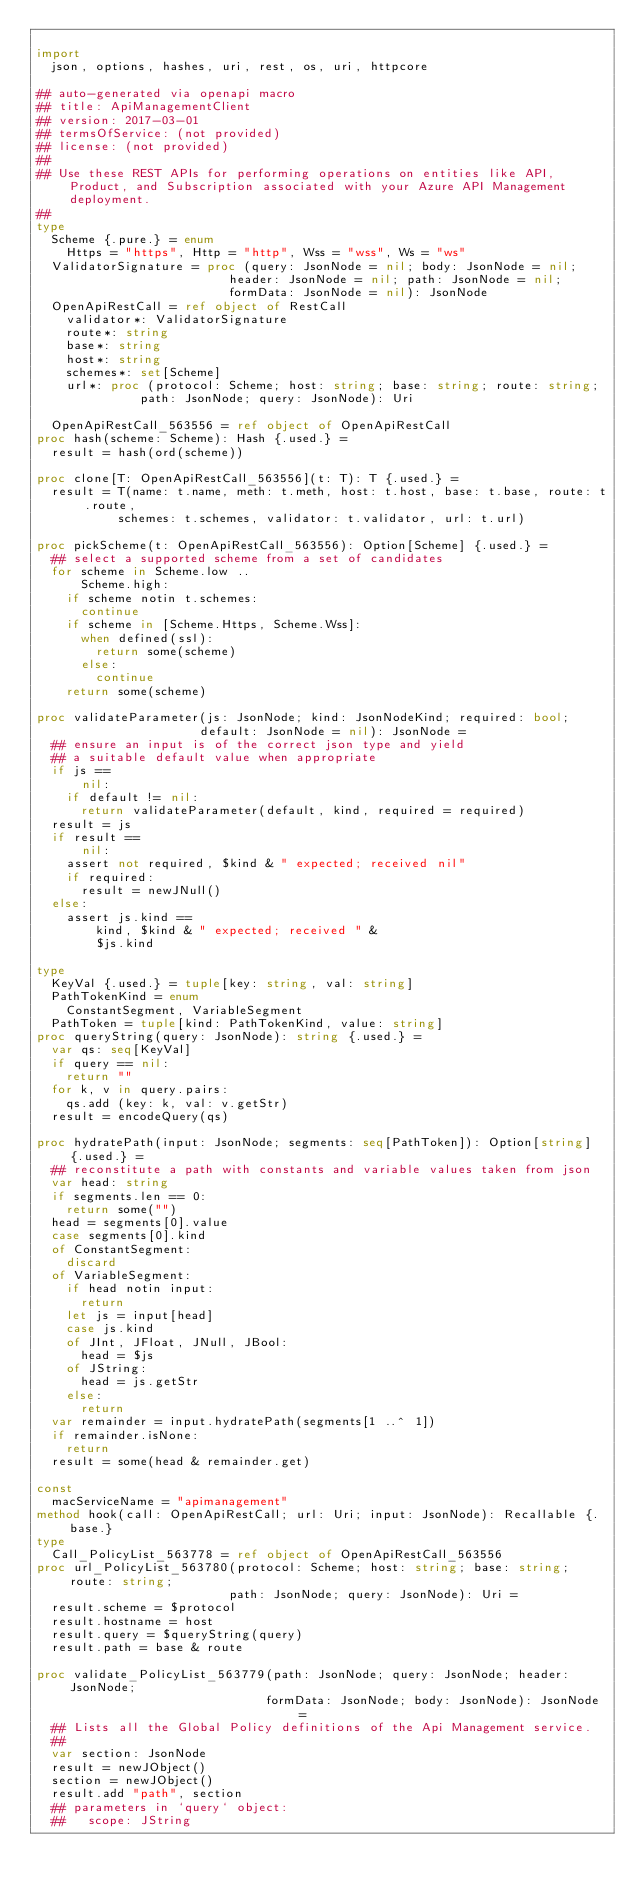Convert code to text. <code><loc_0><loc_0><loc_500><loc_500><_Nim_>
import
  json, options, hashes, uri, rest, os, uri, httpcore

## auto-generated via openapi macro
## title: ApiManagementClient
## version: 2017-03-01
## termsOfService: (not provided)
## license: (not provided)
## 
## Use these REST APIs for performing operations on entities like API, Product, and Subscription associated with your Azure API Management deployment.
## 
type
  Scheme {.pure.} = enum
    Https = "https", Http = "http", Wss = "wss", Ws = "ws"
  ValidatorSignature = proc (query: JsonNode = nil; body: JsonNode = nil;
                          header: JsonNode = nil; path: JsonNode = nil;
                          formData: JsonNode = nil): JsonNode
  OpenApiRestCall = ref object of RestCall
    validator*: ValidatorSignature
    route*: string
    base*: string
    host*: string
    schemes*: set[Scheme]
    url*: proc (protocol: Scheme; host: string; base: string; route: string;
              path: JsonNode; query: JsonNode): Uri

  OpenApiRestCall_563556 = ref object of OpenApiRestCall
proc hash(scheme: Scheme): Hash {.used.} =
  result = hash(ord(scheme))

proc clone[T: OpenApiRestCall_563556](t: T): T {.used.} =
  result = T(name: t.name, meth: t.meth, host: t.host, base: t.base, route: t.route,
           schemes: t.schemes, validator: t.validator, url: t.url)

proc pickScheme(t: OpenApiRestCall_563556): Option[Scheme] {.used.} =
  ## select a supported scheme from a set of candidates
  for scheme in Scheme.low ..
      Scheme.high:
    if scheme notin t.schemes:
      continue
    if scheme in [Scheme.Https, Scheme.Wss]:
      when defined(ssl):
        return some(scheme)
      else:
        continue
    return some(scheme)

proc validateParameter(js: JsonNode; kind: JsonNodeKind; required: bool;
                      default: JsonNode = nil): JsonNode =
  ## ensure an input is of the correct json type and yield
  ## a suitable default value when appropriate
  if js ==
      nil:
    if default != nil:
      return validateParameter(default, kind, required = required)
  result = js
  if result ==
      nil:
    assert not required, $kind & " expected; received nil"
    if required:
      result = newJNull()
  else:
    assert js.kind ==
        kind, $kind & " expected; received " &
        $js.kind

type
  KeyVal {.used.} = tuple[key: string, val: string]
  PathTokenKind = enum
    ConstantSegment, VariableSegment
  PathToken = tuple[kind: PathTokenKind, value: string]
proc queryString(query: JsonNode): string {.used.} =
  var qs: seq[KeyVal]
  if query == nil:
    return ""
  for k, v in query.pairs:
    qs.add (key: k, val: v.getStr)
  result = encodeQuery(qs)

proc hydratePath(input: JsonNode; segments: seq[PathToken]): Option[string] {.used.} =
  ## reconstitute a path with constants and variable values taken from json
  var head: string
  if segments.len == 0:
    return some("")
  head = segments[0].value
  case segments[0].kind
  of ConstantSegment:
    discard
  of VariableSegment:
    if head notin input:
      return
    let js = input[head]
    case js.kind
    of JInt, JFloat, JNull, JBool:
      head = $js
    of JString:
      head = js.getStr
    else:
      return
  var remainder = input.hydratePath(segments[1 ..^ 1])
  if remainder.isNone:
    return
  result = some(head & remainder.get)

const
  macServiceName = "apimanagement"
method hook(call: OpenApiRestCall; url: Uri; input: JsonNode): Recallable {.base.}
type
  Call_PolicyList_563778 = ref object of OpenApiRestCall_563556
proc url_PolicyList_563780(protocol: Scheme; host: string; base: string; route: string;
                          path: JsonNode; query: JsonNode): Uri =
  result.scheme = $protocol
  result.hostname = host
  result.query = $queryString(query)
  result.path = base & route

proc validate_PolicyList_563779(path: JsonNode; query: JsonNode; header: JsonNode;
                               formData: JsonNode; body: JsonNode): JsonNode =
  ## Lists all the Global Policy definitions of the Api Management service.
  ## 
  var section: JsonNode
  result = newJObject()
  section = newJObject()
  result.add "path", section
  ## parameters in `query` object:
  ##   scope: JString</code> 